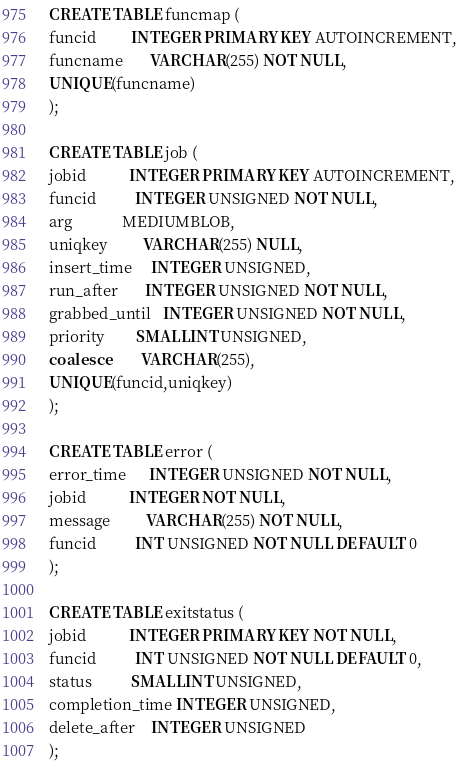<code> <loc_0><loc_0><loc_500><loc_500><_SQL_>CREATE TABLE funcmap (
funcid         INTEGER PRIMARY KEY AUTOINCREMENT,
funcname       VARCHAR(255) NOT NULL,
UNIQUE(funcname)
);

CREATE TABLE job (
jobid           INTEGER PRIMARY KEY AUTOINCREMENT,
funcid          INTEGER UNSIGNED NOT NULL,
arg             MEDIUMBLOB,
uniqkey         VARCHAR(255) NULL,
insert_time     INTEGER UNSIGNED,
run_after       INTEGER UNSIGNED NOT NULL,
grabbed_until   INTEGER UNSIGNED NOT NULL,
priority        SMALLINT UNSIGNED,
coalesce        VARCHAR(255),
UNIQUE(funcid,uniqkey)
);

CREATE TABLE error (
error_time      INTEGER UNSIGNED NOT NULL,
jobid           INTEGER NOT NULL,
message         VARCHAR(255) NOT NULL,
funcid          INT UNSIGNED NOT NULL DEFAULT 0
);

CREATE TABLE exitstatus (
jobid           INTEGER PRIMARY KEY NOT NULL,
funcid          INT UNSIGNED NOT NULL DEFAULT 0,
status          SMALLINT UNSIGNED,
completion_time INTEGER UNSIGNED,
delete_after    INTEGER UNSIGNED
);</code> 